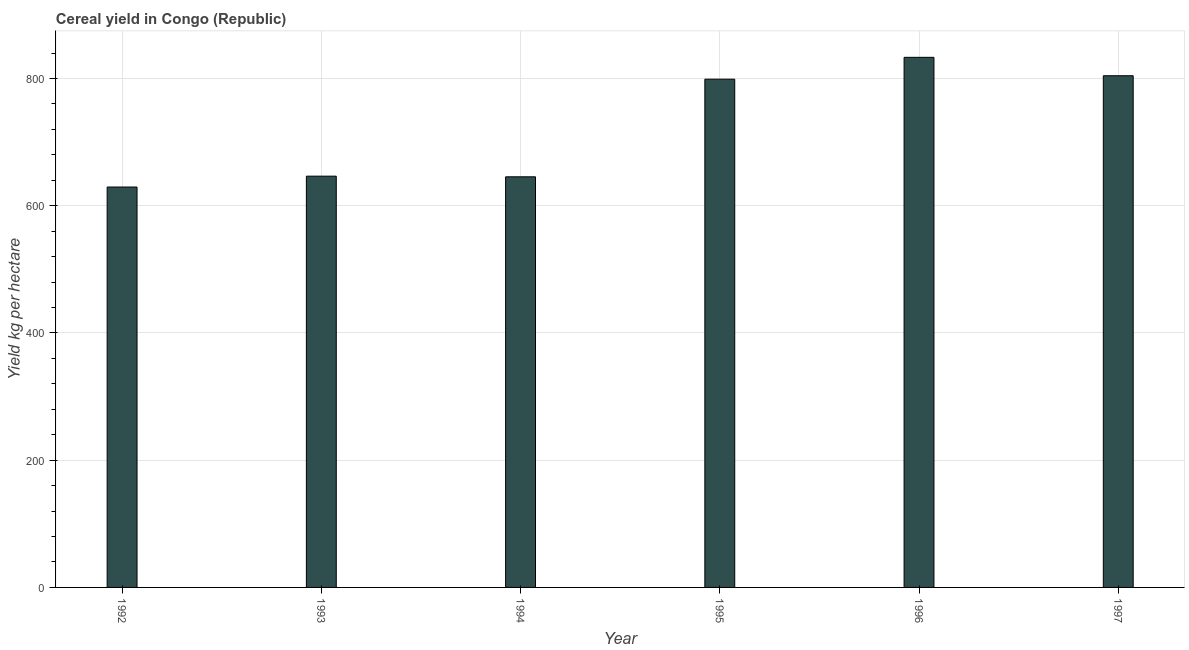What is the title of the graph?
Offer a terse response. Cereal yield in Congo (Republic). What is the label or title of the Y-axis?
Offer a terse response. Yield kg per hectare. What is the cereal yield in 1993?
Provide a short and direct response. 646.49. Across all years, what is the maximum cereal yield?
Your answer should be very brief. 833.29. Across all years, what is the minimum cereal yield?
Provide a succinct answer. 629.41. In which year was the cereal yield maximum?
Make the answer very short. 1996. What is the sum of the cereal yield?
Make the answer very short. 4357.94. What is the difference between the cereal yield in 1992 and 1997?
Provide a short and direct response. -174.93. What is the average cereal yield per year?
Provide a short and direct response. 726.32. What is the median cereal yield?
Offer a terse response. 722.71. In how many years, is the cereal yield greater than 480 kg per hectare?
Provide a succinct answer. 6. Is the difference between the cereal yield in 1993 and 1997 greater than the difference between any two years?
Offer a terse response. No. What is the difference between the highest and the second highest cereal yield?
Your response must be concise. 28.95. What is the difference between the highest and the lowest cereal yield?
Provide a succinct answer. 203.88. In how many years, is the cereal yield greater than the average cereal yield taken over all years?
Provide a succinct answer. 3. Are all the bars in the graph horizontal?
Provide a succinct answer. No. What is the difference between two consecutive major ticks on the Y-axis?
Your answer should be very brief. 200. Are the values on the major ticks of Y-axis written in scientific E-notation?
Keep it short and to the point. No. What is the Yield kg per hectare of 1992?
Keep it short and to the point. 629.41. What is the Yield kg per hectare of 1993?
Your answer should be very brief. 646.49. What is the Yield kg per hectare in 1994?
Keep it short and to the point. 645.48. What is the Yield kg per hectare of 1995?
Your response must be concise. 798.93. What is the Yield kg per hectare in 1996?
Your answer should be compact. 833.29. What is the Yield kg per hectare of 1997?
Offer a terse response. 804.34. What is the difference between the Yield kg per hectare in 1992 and 1993?
Provide a succinct answer. -17.08. What is the difference between the Yield kg per hectare in 1992 and 1994?
Give a very brief answer. -16.07. What is the difference between the Yield kg per hectare in 1992 and 1995?
Ensure brevity in your answer.  -169.53. What is the difference between the Yield kg per hectare in 1992 and 1996?
Offer a terse response. -203.88. What is the difference between the Yield kg per hectare in 1992 and 1997?
Your answer should be very brief. -174.93. What is the difference between the Yield kg per hectare in 1993 and 1994?
Keep it short and to the point. 1.01. What is the difference between the Yield kg per hectare in 1993 and 1995?
Your response must be concise. -152.44. What is the difference between the Yield kg per hectare in 1993 and 1996?
Provide a succinct answer. -186.8. What is the difference between the Yield kg per hectare in 1993 and 1997?
Offer a terse response. -157.84. What is the difference between the Yield kg per hectare in 1994 and 1995?
Make the answer very short. -153.46. What is the difference between the Yield kg per hectare in 1994 and 1996?
Make the answer very short. -187.81. What is the difference between the Yield kg per hectare in 1994 and 1997?
Provide a succinct answer. -158.86. What is the difference between the Yield kg per hectare in 1995 and 1996?
Your answer should be compact. -34.35. What is the difference between the Yield kg per hectare in 1995 and 1997?
Keep it short and to the point. -5.4. What is the difference between the Yield kg per hectare in 1996 and 1997?
Make the answer very short. 28.95. What is the ratio of the Yield kg per hectare in 1992 to that in 1994?
Provide a short and direct response. 0.97. What is the ratio of the Yield kg per hectare in 1992 to that in 1995?
Make the answer very short. 0.79. What is the ratio of the Yield kg per hectare in 1992 to that in 1996?
Your answer should be very brief. 0.76. What is the ratio of the Yield kg per hectare in 1992 to that in 1997?
Offer a very short reply. 0.78. What is the ratio of the Yield kg per hectare in 1993 to that in 1995?
Give a very brief answer. 0.81. What is the ratio of the Yield kg per hectare in 1993 to that in 1996?
Your answer should be compact. 0.78. What is the ratio of the Yield kg per hectare in 1993 to that in 1997?
Your response must be concise. 0.8. What is the ratio of the Yield kg per hectare in 1994 to that in 1995?
Ensure brevity in your answer.  0.81. What is the ratio of the Yield kg per hectare in 1994 to that in 1996?
Offer a terse response. 0.78. What is the ratio of the Yield kg per hectare in 1994 to that in 1997?
Provide a succinct answer. 0.8. What is the ratio of the Yield kg per hectare in 1996 to that in 1997?
Provide a short and direct response. 1.04. 